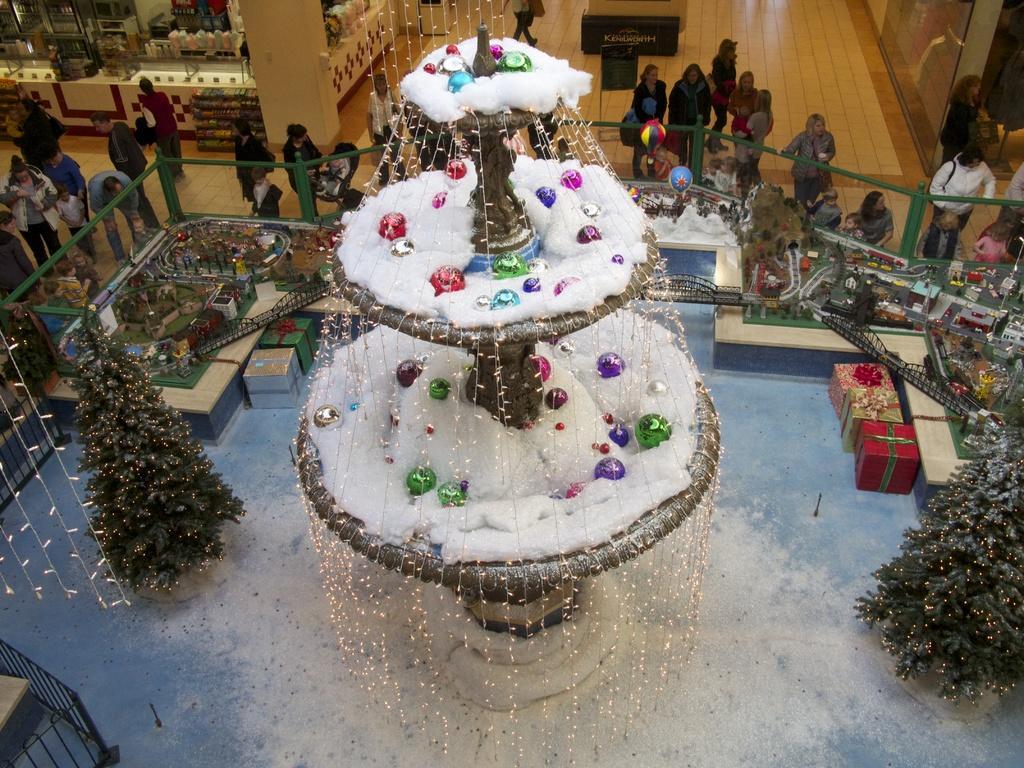How would you summarize this image in a sentence or two? In this image I can see a three layer stand in the centre and on it I can see snow, lights and other decorations. On the both sides of the image I can see two Christmas trees and on it I can see lights as decorations. I can also see few gift boxes and miniature set in the centre of this image. On the top side of this image I can see a store and number of people are standing. 